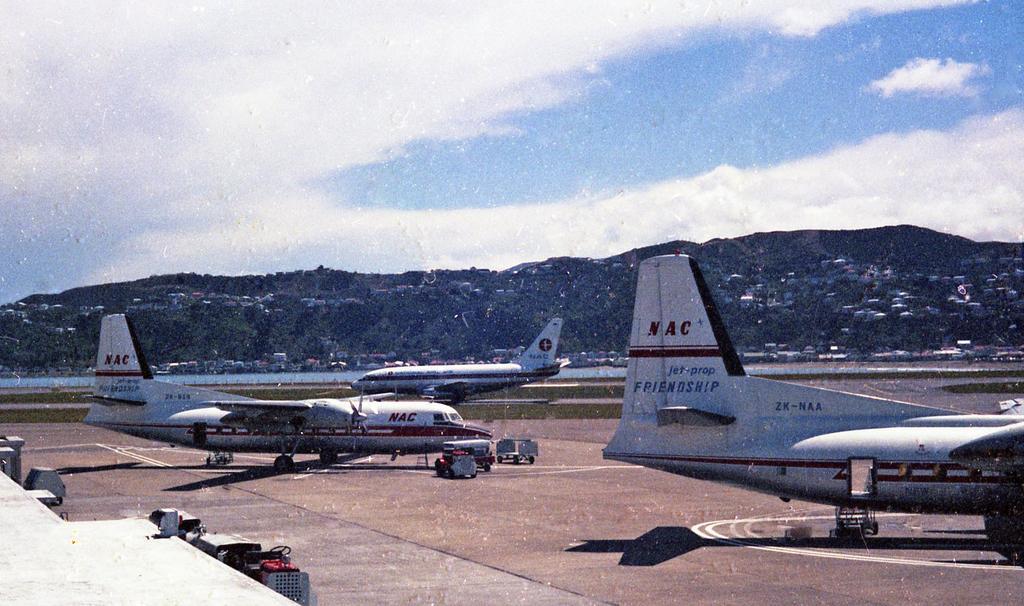In one or two sentences, can you explain what this image depicts? In this image there are aeroplanes. At the bottom we can see a runway. In the background there is a hill and sky. 